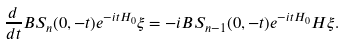Convert formula to latex. <formula><loc_0><loc_0><loc_500><loc_500>\frac { d } { d t } B S _ { n } ( 0 , - t ) e ^ { - i t H _ { 0 } } \xi = - i B S _ { n - 1 } ( 0 , - t ) e ^ { - i t H _ { 0 } } H \xi .</formula> 